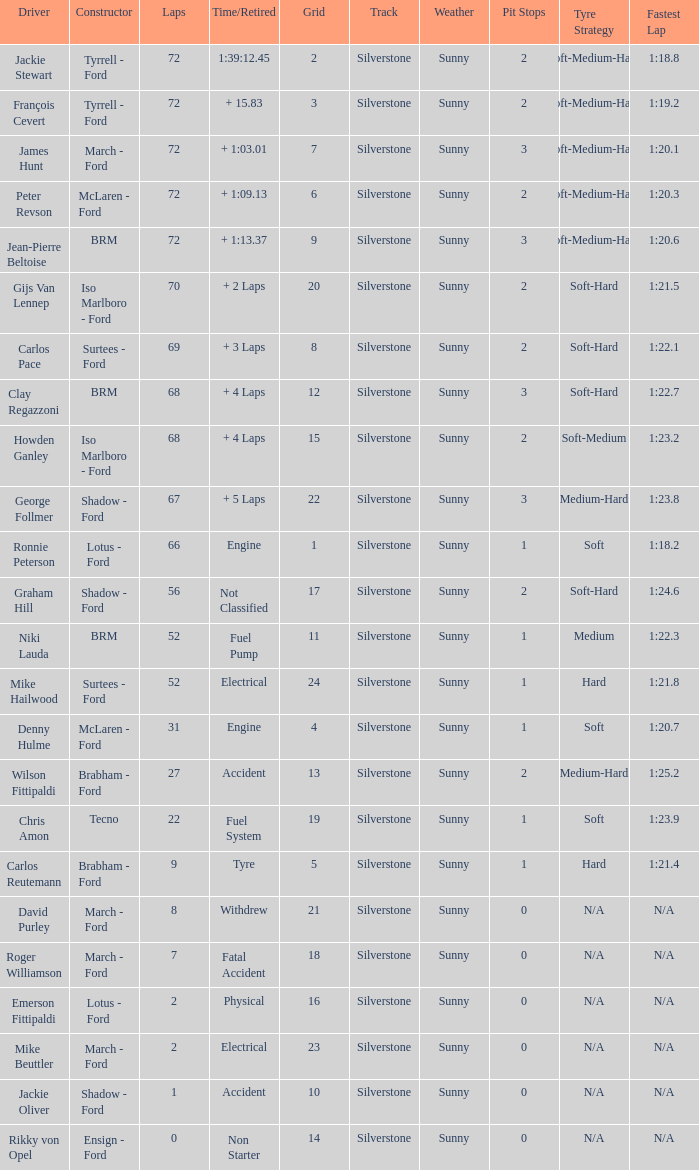What is the top grid that laps less than 66 and a retried engine? 4.0. 